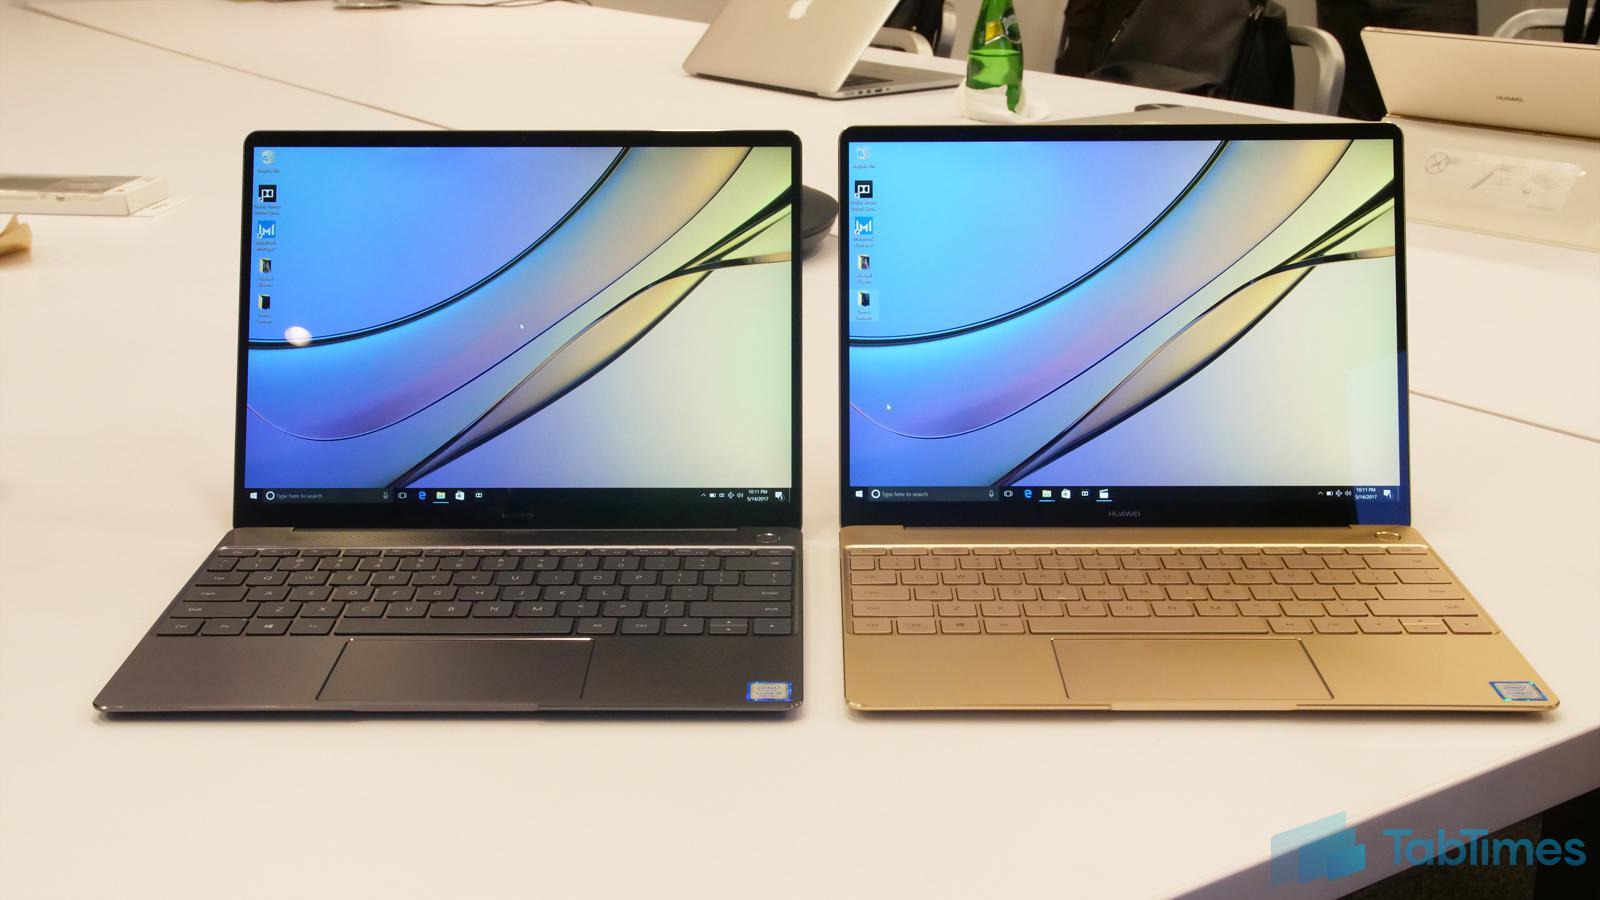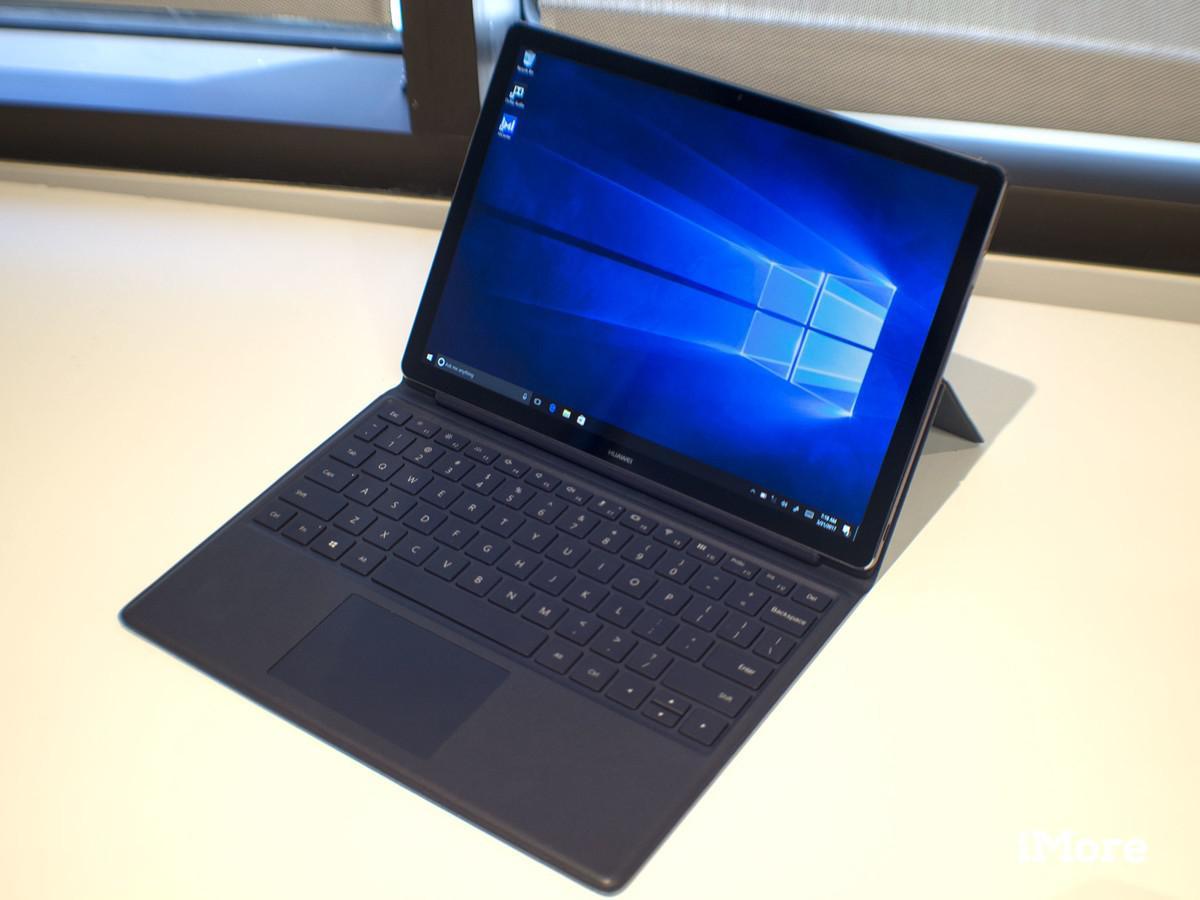The first image is the image on the left, the second image is the image on the right. Analyze the images presented: Is the assertion "One image shows side-by-side open laptops and the other shows a single open laptop, and all laptops are angled somewhat leftward and display curving lines on the screen." valid? Answer yes or no. No. The first image is the image on the left, the second image is the image on the right. Examine the images to the left and right. Is the description "All the desktops have the same design." accurate? Answer yes or no. No. 